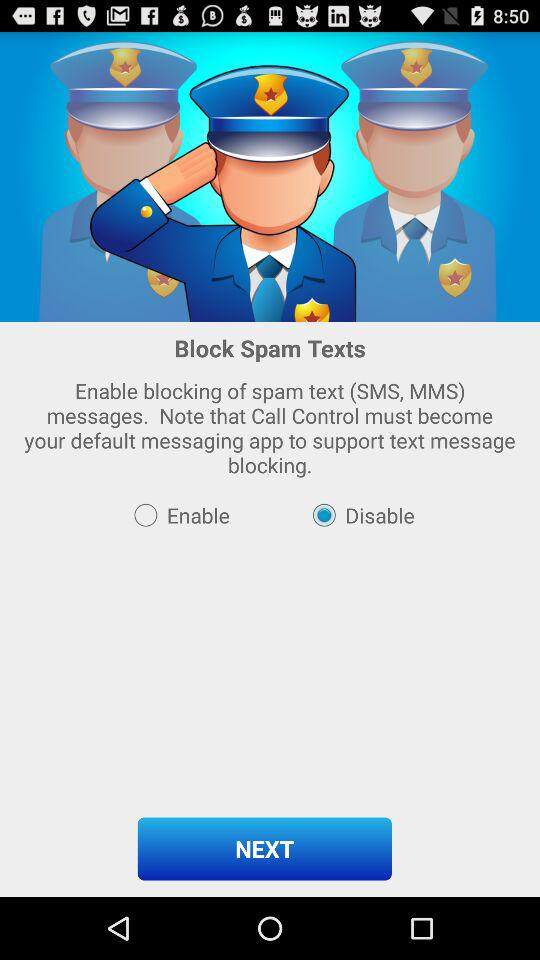What is the status of "Block Spam Texts"? The status of "Block Spam Texts" is "Disable". 